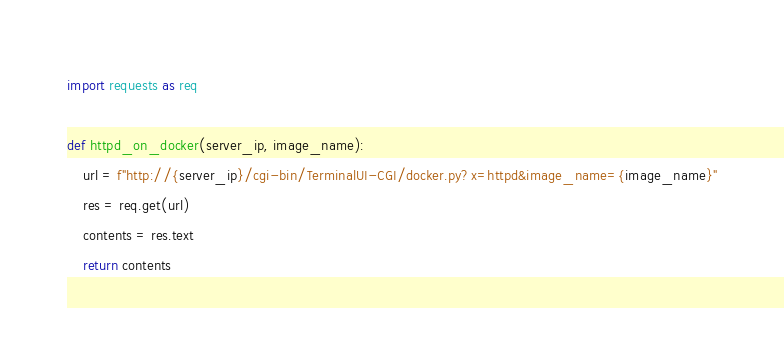Convert code to text. <code><loc_0><loc_0><loc_500><loc_500><_Python_>import requests as req

def httpd_on_docker(server_ip, image_name):
    url = f"http://{server_ip}/cgi-bin/TerminalUI-CGI/docker.py?x=httpd&image_name={image_name}"
    res = req.get(url)
    contents = res.text
    return contents</code> 